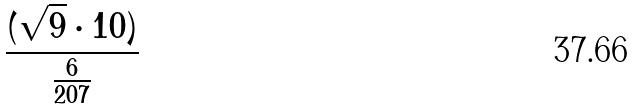Convert formula to latex. <formula><loc_0><loc_0><loc_500><loc_500>\frac { ( \sqrt { 9 } \cdot 1 0 ) } { \frac { 6 } { 2 0 7 } }</formula> 